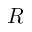Convert formula to latex. <formula><loc_0><loc_0><loc_500><loc_500>R</formula> 